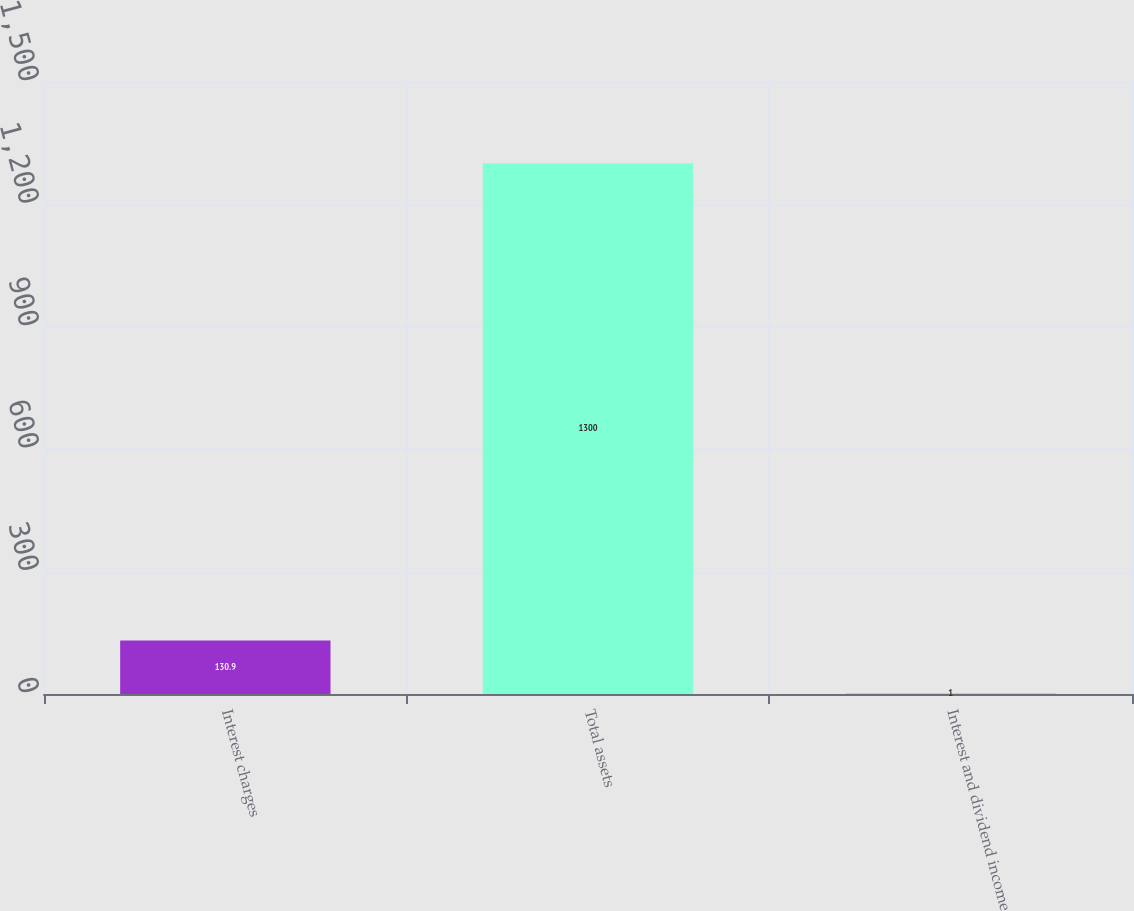<chart> <loc_0><loc_0><loc_500><loc_500><bar_chart><fcel>Interest charges<fcel>Total assets<fcel>Interest and dividend income<nl><fcel>130.9<fcel>1300<fcel>1<nl></chart> 